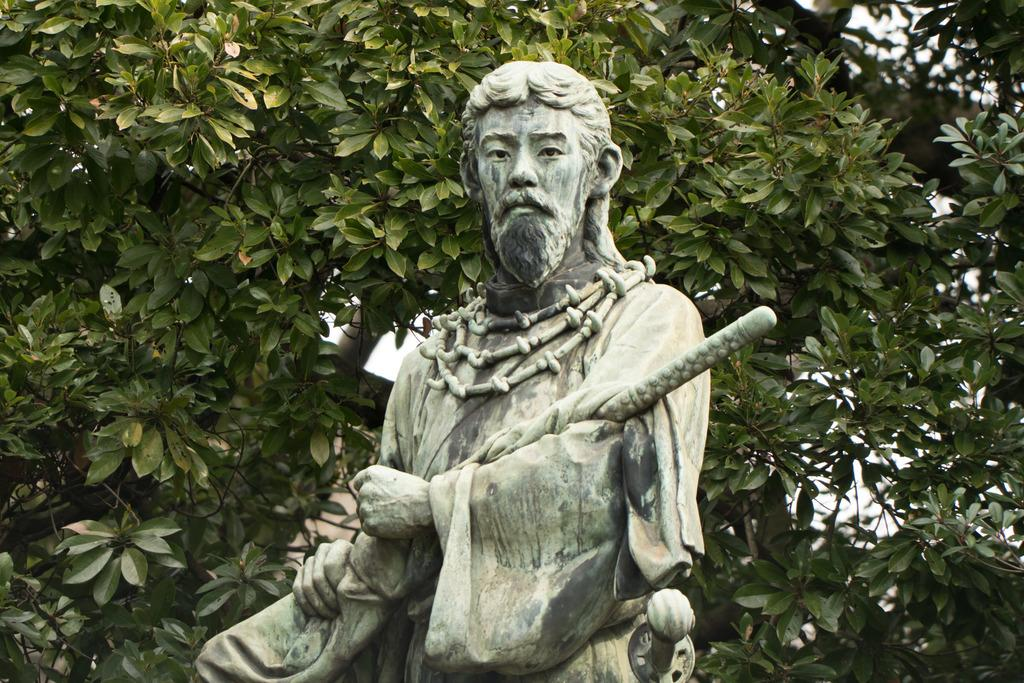What is the main subject of the image? There is a sculpture in the image. What is the sculpture doing in the image? The sculpture is holding an object. What type of vegetation can be seen in the image? There are green leaves visible in the image. How does the sculpture smile in the image? The sculpture does not have the ability to smile, as it is an inanimate object. 